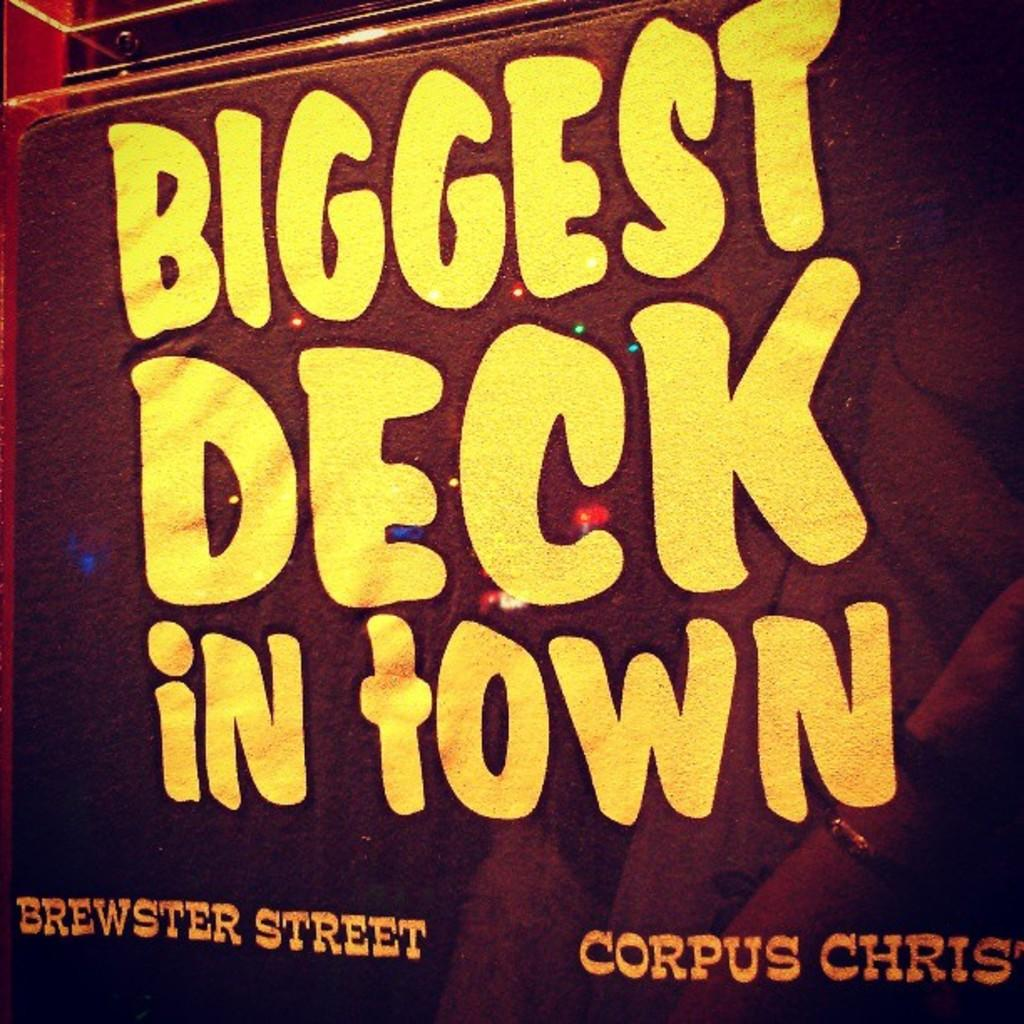What is present in the image that contains information or a message? There is a poster in the image. What can be found on the poster? There is text on the poster. Where is the pail located in the image? There is no pail present in the image. What type of test is being conducted in the image? There is no test being conducted in the image. 